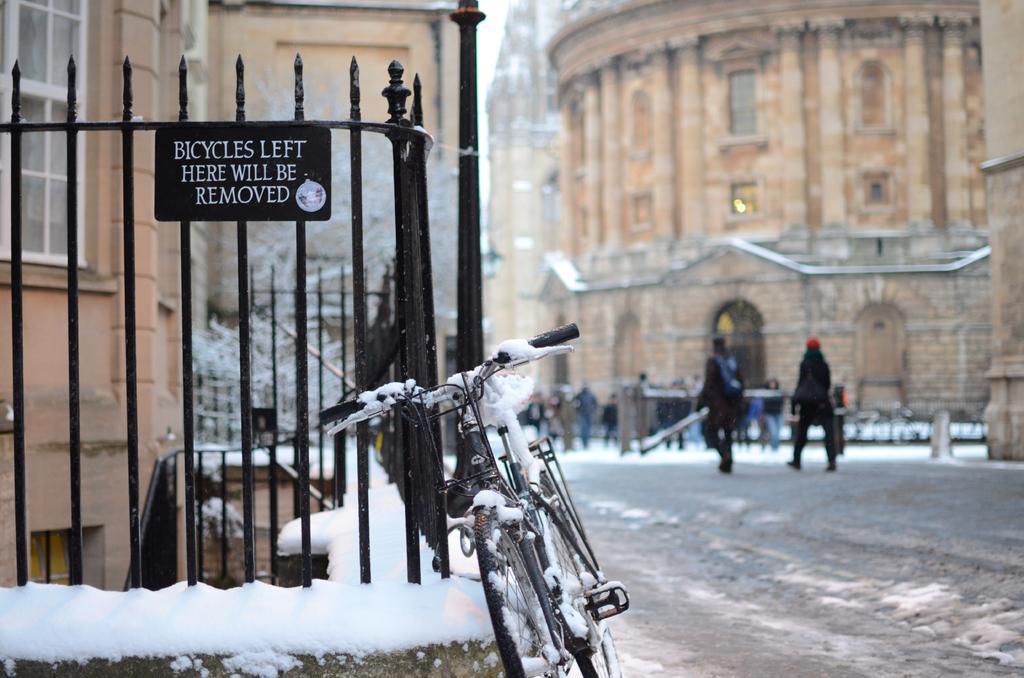Describe this image in one or two sentences. In this image, we can see a black color fence and there is a bicycle, we can see some people walking and there are some buildings. 